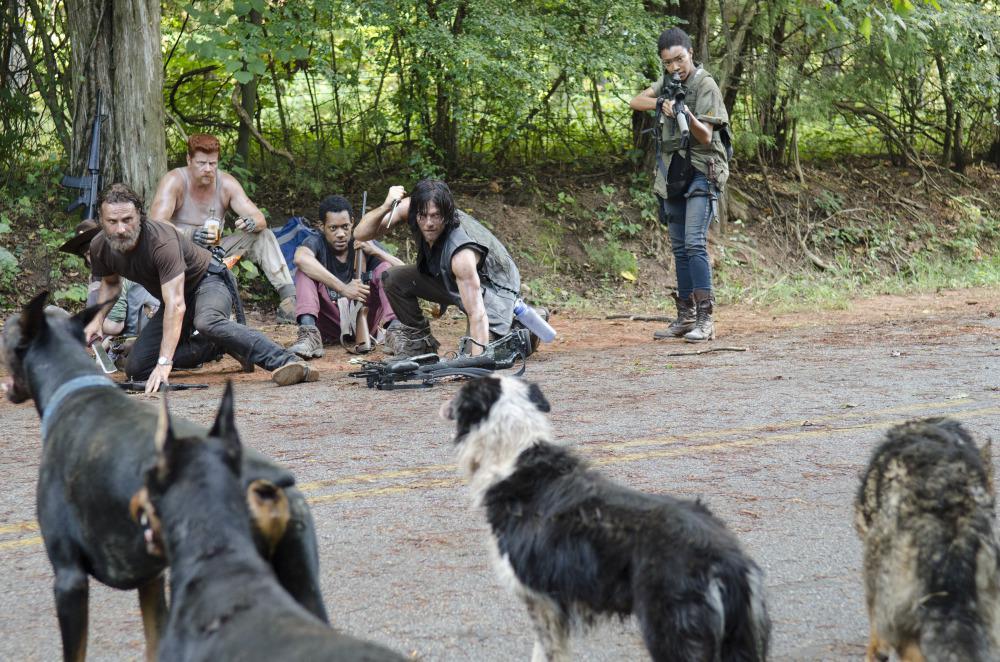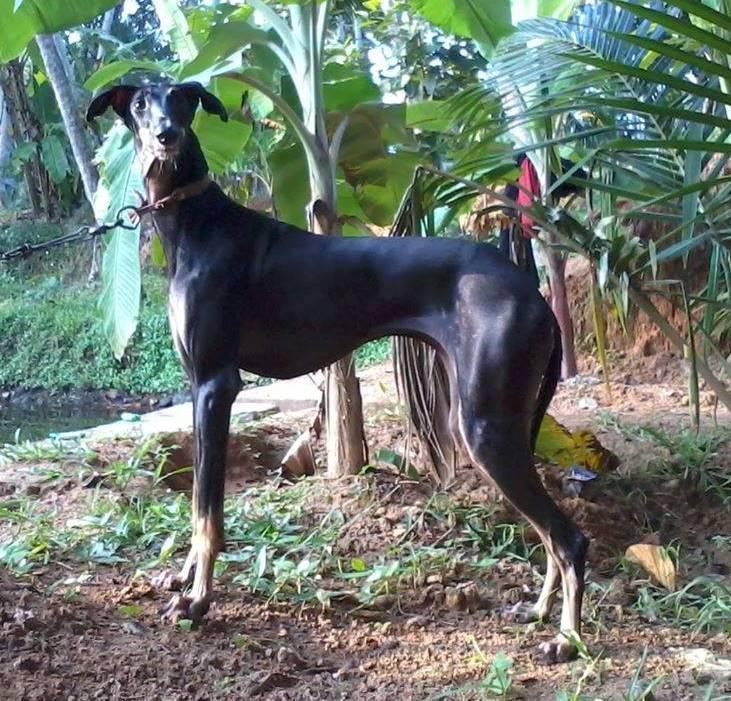The first image is the image on the left, the second image is the image on the right. Evaluate the accuracy of this statement regarding the images: "there are 5 dogs sitting in a row on the grass while wearing collars". Is it true? Answer yes or no. No. 